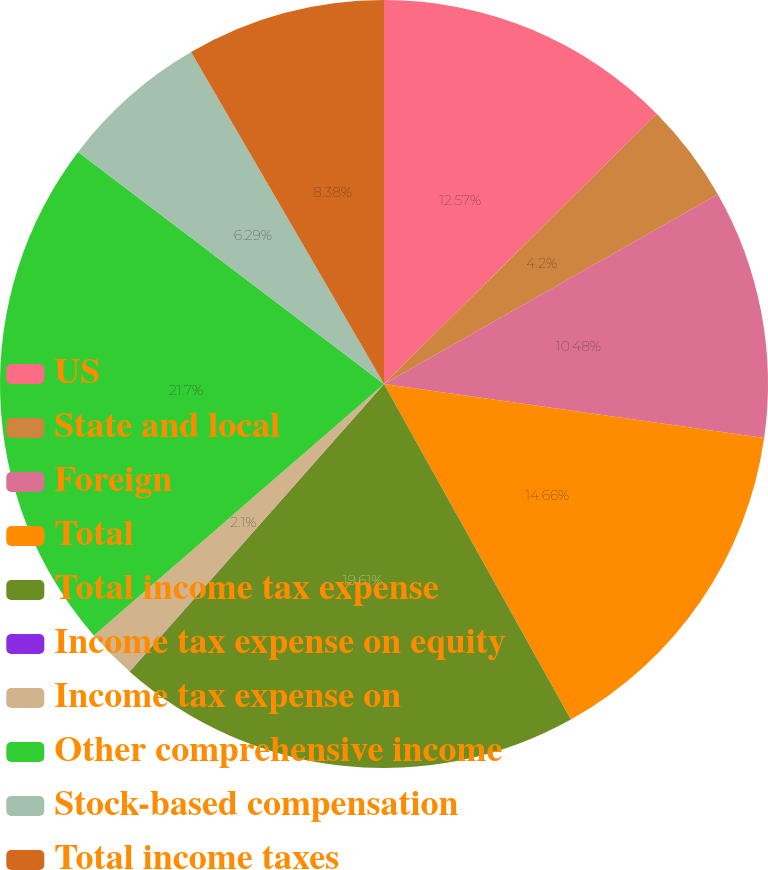Convert chart. <chart><loc_0><loc_0><loc_500><loc_500><pie_chart><fcel>US<fcel>State and local<fcel>Foreign<fcel>Total<fcel>Total income tax expense<fcel>Income tax expense on equity<fcel>Income tax expense on<fcel>Other comprehensive income<fcel>Stock-based compensation<fcel>Total income taxes<nl><fcel>12.57%<fcel>4.2%<fcel>10.48%<fcel>14.66%<fcel>19.61%<fcel>0.01%<fcel>2.1%<fcel>21.7%<fcel>6.29%<fcel>8.38%<nl></chart> 